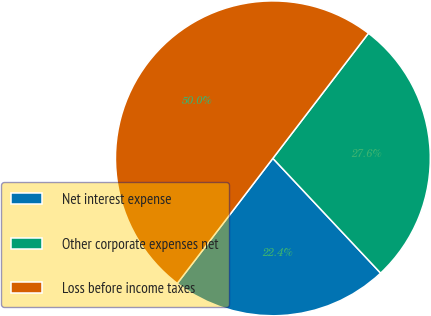Convert chart. <chart><loc_0><loc_0><loc_500><loc_500><pie_chart><fcel>Net interest expense<fcel>Other corporate expenses net<fcel>Loss before income taxes<nl><fcel>22.38%<fcel>27.62%<fcel>50.0%<nl></chart> 